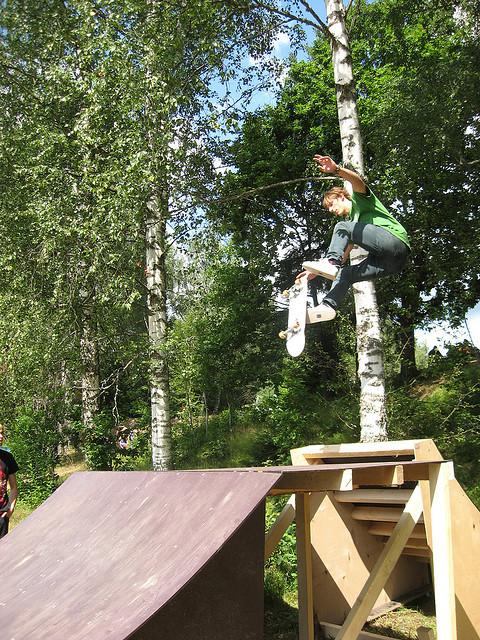What is he on?
Keep it brief. Skateboard. Is it sunny?
Give a very brief answer. Yes. Are the ramps connected?
Short answer required. Yes. What is the material of the platform?
Give a very brief answer. Wood. 